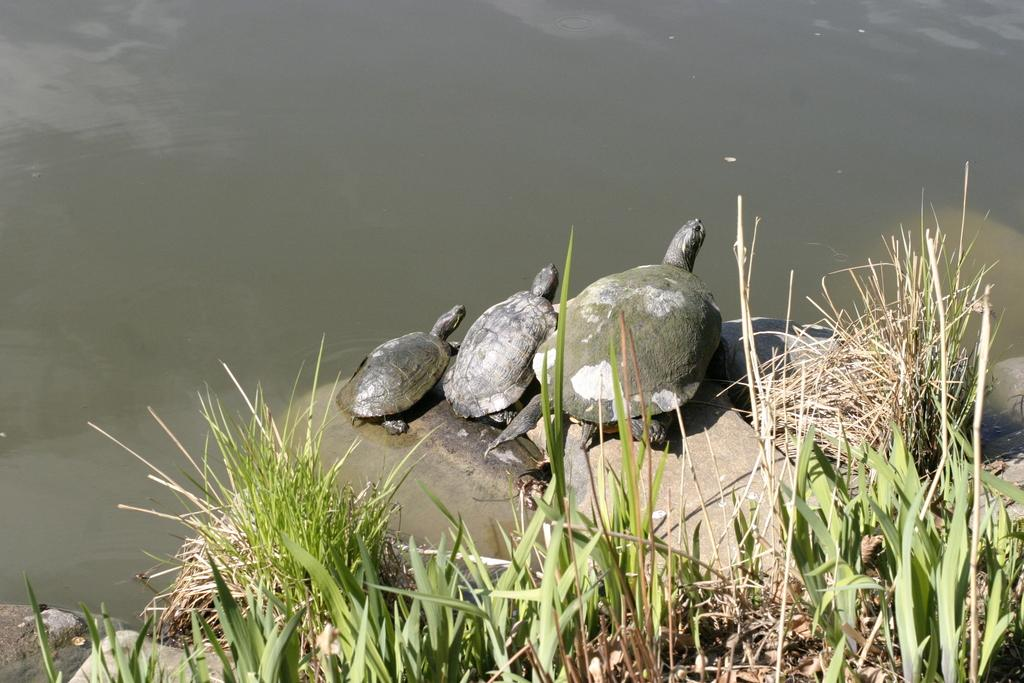What animals can be seen in the image? There are tortoises in the image. What are the tortoises standing on? The tortoises are standing on stones. What type of vegetation is present in the image? There are plants in the image. What can be seen in the background of the image? There is water visible at the back of the image. What type of copper material can be seen in the image? There is no copper material present in the image. What kind of power source is visible in the image? There is no power source visible in the image. 